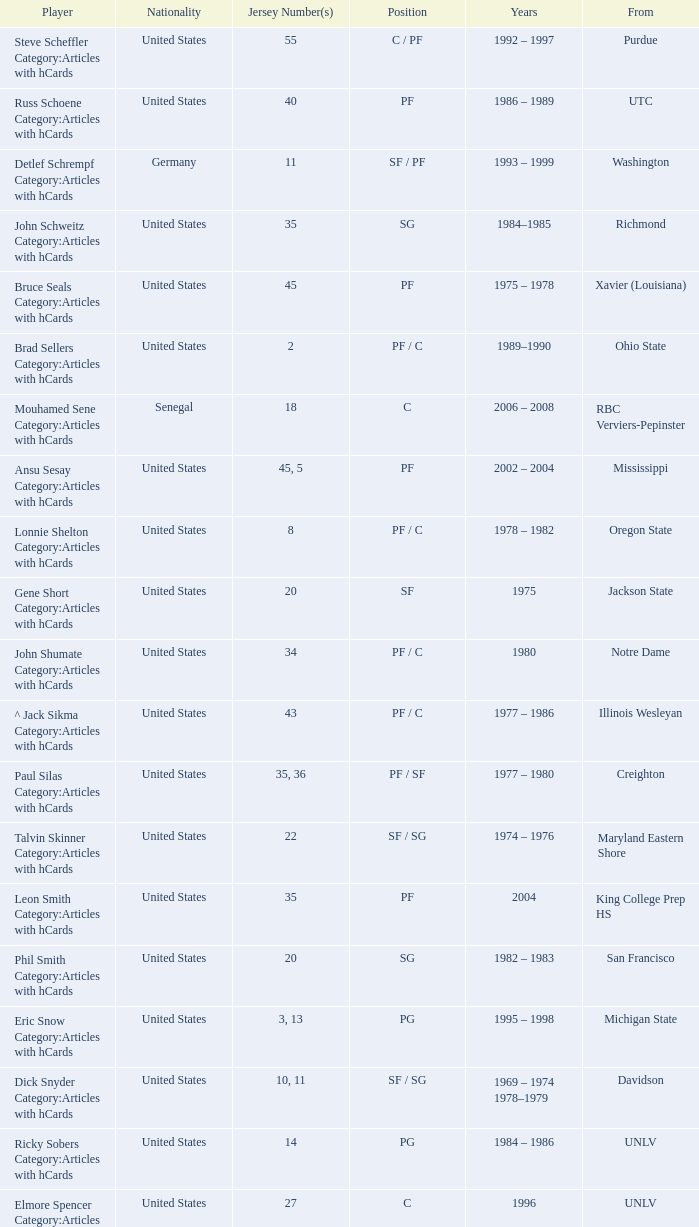Which role does the athlete wearing the number 22 jersey perform? SF / SG. 